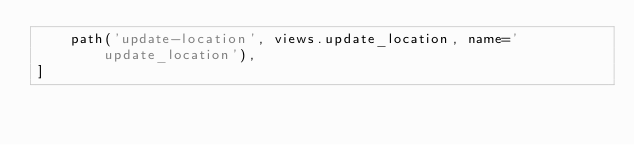Convert code to text. <code><loc_0><loc_0><loc_500><loc_500><_Python_>    path('update-location', views.update_location, name='update_location'),
]
</code> 